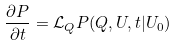<formula> <loc_0><loc_0><loc_500><loc_500>\frac { \partial P } { \partial t } = { \mathcal { L } } _ { Q } P ( Q , U , t | U _ { 0 } )</formula> 